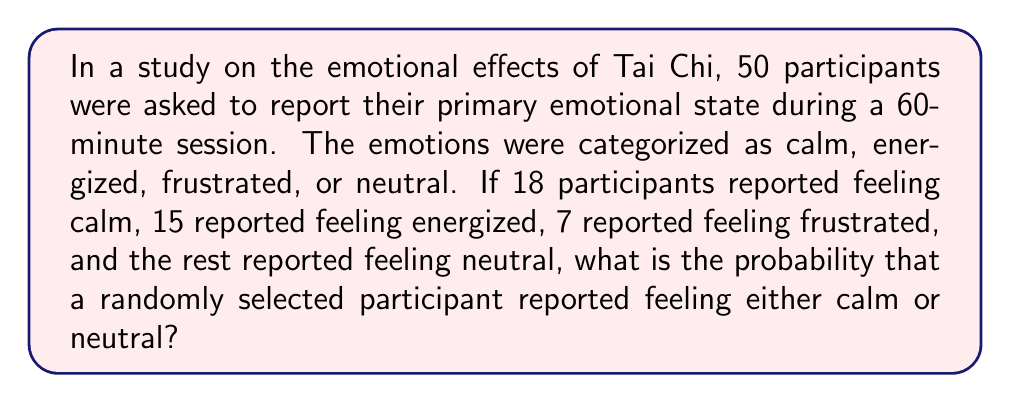Can you solve this math problem? Let's approach this step-by-step:

1) First, let's identify the total number of participants and the number who reported each emotion:
   - Total participants: 50
   - Calm: 18
   - Energized: 15
   - Frustrated: 7
   - Neutral: We need to calculate this

2) To find the number of neutral participants:
   $50 - (18 + 15 + 7) = 50 - 40 = 10$ participants reported feeling neutral

3) Now, we need to find the probability of selecting a participant who reported feeling either calm or neutral:
   - Number of favorable outcomes: Calm + Neutral = $18 + 10 = 28$
   - Total number of possible outcomes: 50

4) The probability is calculated as:

   $$P(\text{Calm or Neutral}) = \frac{\text{Number of favorable outcomes}}{\text{Total number of possible outcomes}}$$

   $$P(\text{Calm or Neutral}) = \frac{28}{50}$$

5) This fraction can be reduced:

   $$P(\text{Calm or Neutral}) = \frac{28}{50} = \frac{14}{25} = 0.56$$

Therefore, the probability of randomly selecting a participant who reported feeling either calm or neutral is $\frac{14}{25}$ or 0.56 or 56%.
Answer: $\frac{14}{25}$ 